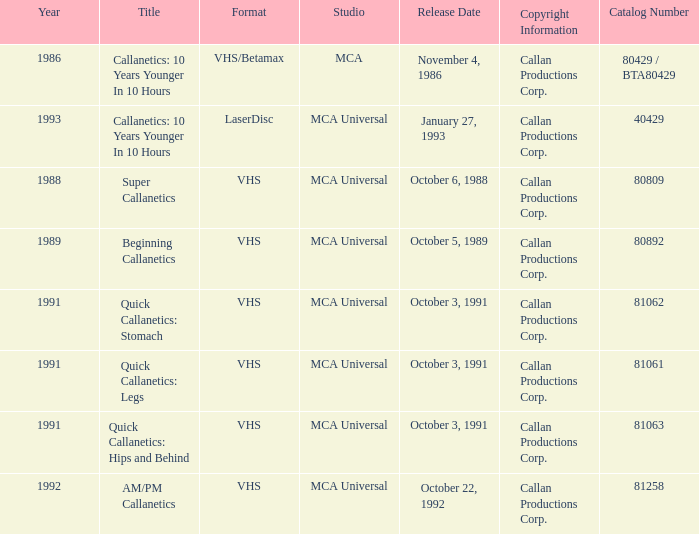Provide the catalog number associated with october 6, 198 80809.0. 